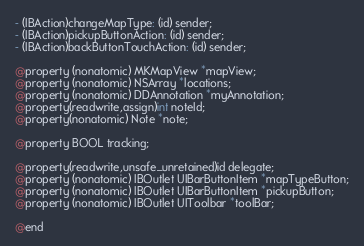Convert code to text. <code><loc_0><loc_0><loc_500><loc_500><_C_>- (IBAction)changeMapType: (id) sender;
- (IBAction)pickupButtonAction: (id) sender;
- (IBAction)backButtonTouchAction: (id) sender;

@property (nonatomic) MKMapView *mapView;
@property (nonatomic) NSArray *locations;
@property (nonatomic) DDAnnotation *myAnnotation;
@property(readwrite,assign)int noteId;
@property(nonatomic) Note *note;

@property BOOL tracking;

@property(readwrite,unsafe_unretained)id delegate;
@property (nonatomic) IBOutlet UIBarButtonItem *mapTypeButton;
@property (nonatomic) IBOutlet UIBarButtonItem *pickupButton;
@property (nonatomic) IBOutlet UIToolbar *toolBar;

@end
</code> 